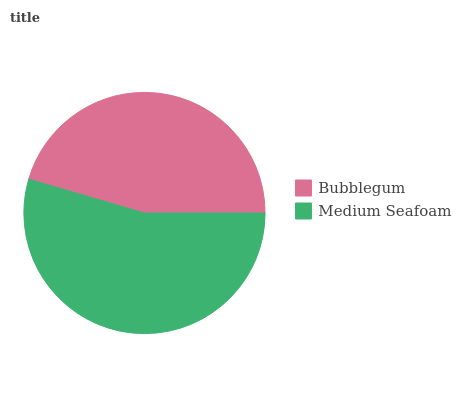Is Bubblegum the minimum?
Answer yes or no. Yes. Is Medium Seafoam the maximum?
Answer yes or no. Yes. Is Medium Seafoam the minimum?
Answer yes or no. No. Is Medium Seafoam greater than Bubblegum?
Answer yes or no. Yes. Is Bubblegum less than Medium Seafoam?
Answer yes or no. Yes. Is Bubblegum greater than Medium Seafoam?
Answer yes or no. No. Is Medium Seafoam less than Bubblegum?
Answer yes or no. No. Is Medium Seafoam the high median?
Answer yes or no. Yes. Is Bubblegum the low median?
Answer yes or no. Yes. Is Bubblegum the high median?
Answer yes or no. No. Is Medium Seafoam the low median?
Answer yes or no. No. 